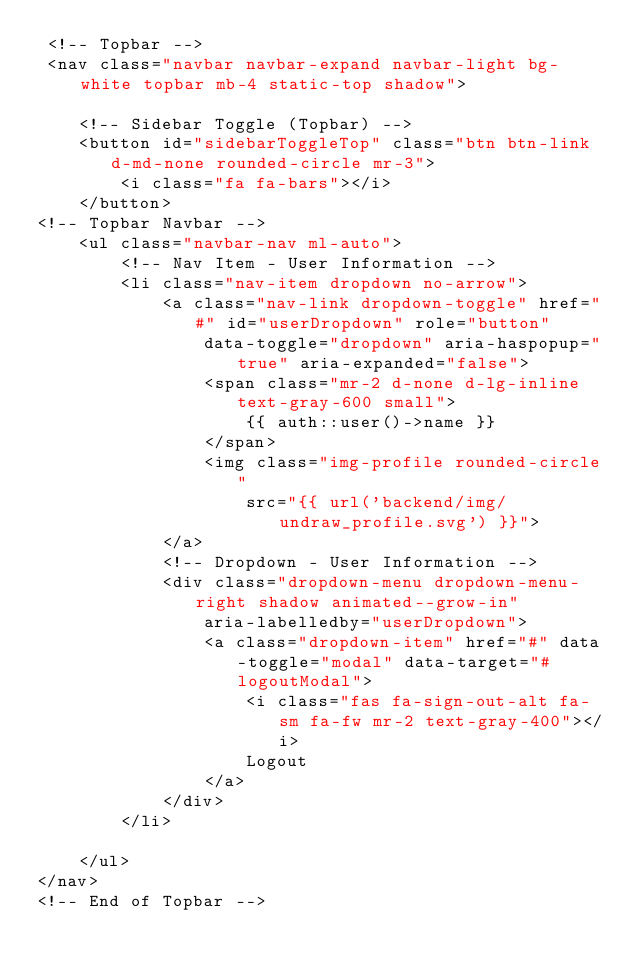Convert code to text. <code><loc_0><loc_0><loc_500><loc_500><_PHP_> <!-- Topbar -->
 <nav class="navbar navbar-expand navbar-light bg-white topbar mb-4 static-top shadow">

    <!-- Sidebar Toggle (Topbar) -->
    <button id="sidebarToggleTop" class="btn btn-link d-md-none rounded-circle mr-3">
        <i class="fa fa-bars"></i>
    </button>           
<!-- Topbar Navbar -->
    <ul class="navbar-nav ml-auto">
        <!-- Nav Item - User Information -->
        <li class="nav-item dropdown no-arrow">
            <a class="nav-link dropdown-toggle" href="#" id="userDropdown" role="button"
                data-toggle="dropdown" aria-haspopup="true" aria-expanded="false">
                <span class="mr-2 d-none d-lg-inline text-gray-600 small">
                    {{ auth::user()->name }}
                </span>
                <img class="img-profile rounded-circle"
                    src="{{ url('backend/img/undraw_profile.svg') }}">
            </a>
            <!-- Dropdown - User Information -->
            <div class="dropdown-menu dropdown-menu-right shadow animated--grow-in"
                aria-labelledby="userDropdown">
                <a class="dropdown-item" href="#" data-toggle="modal" data-target="#logoutModal">
                    <i class="fas fa-sign-out-alt fa-sm fa-fw mr-2 text-gray-400"></i>
                    Logout
                </a>
            </div>
        </li>

    </ul>
</nav>
<!-- End of Topbar -->


</code> 